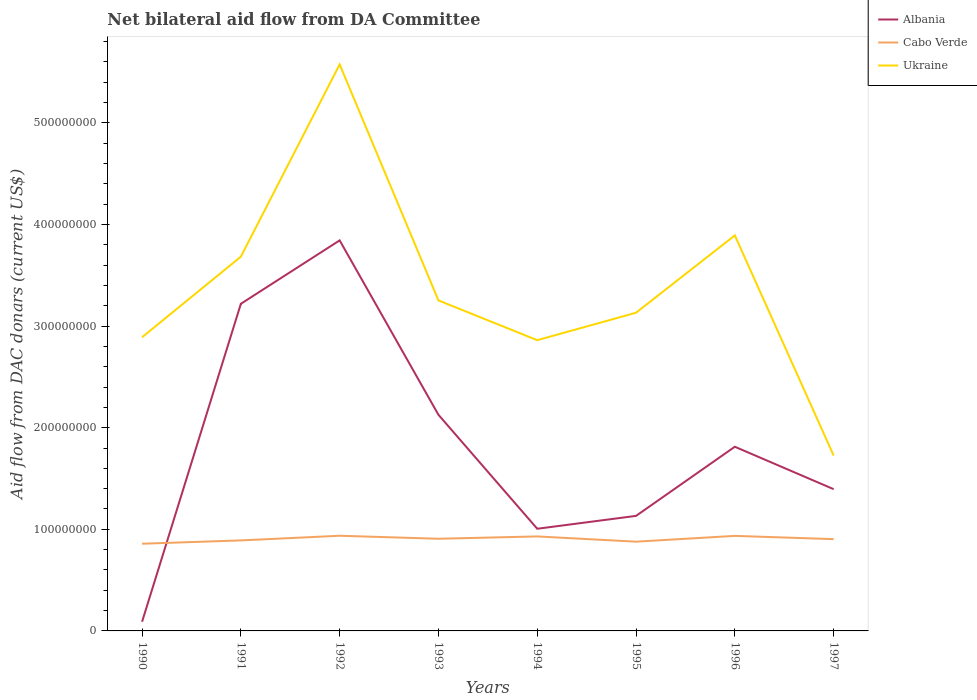How many different coloured lines are there?
Provide a succinct answer. 3. Across all years, what is the maximum aid flow in in Cabo Verde?
Keep it short and to the point. 8.58e+07. What is the total aid flow in in Cabo Verde in the graph?
Your answer should be compact. -4.59e+06. What is the difference between the highest and the second highest aid flow in in Cabo Verde?
Make the answer very short. 7.85e+06. Is the aid flow in in Albania strictly greater than the aid flow in in Cabo Verde over the years?
Ensure brevity in your answer.  No. How many years are there in the graph?
Your answer should be very brief. 8. What is the difference between two consecutive major ticks on the Y-axis?
Ensure brevity in your answer.  1.00e+08. Are the values on the major ticks of Y-axis written in scientific E-notation?
Your answer should be very brief. No. How are the legend labels stacked?
Offer a terse response. Vertical. What is the title of the graph?
Provide a short and direct response. Net bilateral aid flow from DA Committee. What is the label or title of the X-axis?
Offer a terse response. Years. What is the label or title of the Y-axis?
Provide a succinct answer. Aid flow from DAC donars (current US$). What is the Aid flow from DAC donars (current US$) in Albania in 1990?
Make the answer very short. 9.02e+06. What is the Aid flow from DAC donars (current US$) in Cabo Verde in 1990?
Ensure brevity in your answer.  8.58e+07. What is the Aid flow from DAC donars (current US$) in Ukraine in 1990?
Offer a terse response. 2.89e+08. What is the Aid flow from DAC donars (current US$) of Albania in 1991?
Give a very brief answer. 3.22e+08. What is the Aid flow from DAC donars (current US$) in Cabo Verde in 1991?
Keep it short and to the point. 8.91e+07. What is the Aid flow from DAC donars (current US$) of Ukraine in 1991?
Provide a succinct answer. 3.68e+08. What is the Aid flow from DAC donars (current US$) in Albania in 1992?
Give a very brief answer. 3.84e+08. What is the Aid flow from DAC donars (current US$) of Cabo Verde in 1992?
Give a very brief answer. 9.37e+07. What is the Aid flow from DAC donars (current US$) of Ukraine in 1992?
Keep it short and to the point. 5.57e+08. What is the Aid flow from DAC donars (current US$) in Albania in 1993?
Ensure brevity in your answer.  2.13e+08. What is the Aid flow from DAC donars (current US$) in Cabo Verde in 1993?
Keep it short and to the point. 9.07e+07. What is the Aid flow from DAC donars (current US$) in Ukraine in 1993?
Your answer should be very brief. 3.25e+08. What is the Aid flow from DAC donars (current US$) in Albania in 1994?
Make the answer very short. 1.01e+08. What is the Aid flow from DAC donars (current US$) in Cabo Verde in 1994?
Make the answer very short. 9.30e+07. What is the Aid flow from DAC donars (current US$) of Ukraine in 1994?
Your answer should be very brief. 2.86e+08. What is the Aid flow from DAC donars (current US$) in Albania in 1995?
Make the answer very short. 1.13e+08. What is the Aid flow from DAC donars (current US$) of Cabo Verde in 1995?
Ensure brevity in your answer.  8.78e+07. What is the Aid flow from DAC donars (current US$) of Ukraine in 1995?
Offer a terse response. 3.13e+08. What is the Aid flow from DAC donars (current US$) of Albania in 1996?
Offer a terse response. 1.81e+08. What is the Aid flow from DAC donars (current US$) of Cabo Verde in 1996?
Provide a short and direct response. 9.35e+07. What is the Aid flow from DAC donars (current US$) of Ukraine in 1996?
Your answer should be compact. 3.89e+08. What is the Aid flow from DAC donars (current US$) of Albania in 1997?
Provide a succinct answer. 1.40e+08. What is the Aid flow from DAC donars (current US$) of Cabo Verde in 1997?
Give a very brief answer. 9.03e+07. What is the Aid flow from DAC donars (current US$) of Ukraine in 1997?
Your answer should be very brief. 1.73e+08. Across all years, what is the maximum Aid flow from DAC donars (current US$) of Albania?
Make the answer very short. 3.84e+08. Across all years, what is the maximum Aid flow from DAC donars (current US$) in Cabo Verde?
Make the answer very short. 9.37e+07. Across all years, what is the maximum Aid flow from DAC donars (current US$) in Ukraine?
Make the answer very short. 5.57e+08. Across all years, what is the minimum Aid flow from DAC donars (current US$) of Albania?
Keep it short and to the point. 9.02e+06. Across all years, what is the minimum Aid flow from DAC donars (current US$) of Cabo Verde?
Your response must be concise. 8.58e+07. Across all years, what is the minimum Aid flow from DAC donars (current US$) in Ukraine?
Your answer should be very brief. 1.73e+08. What is the total Aid flow from DAC donars (current US$) in Albania in the graph?
Offer a terse response. 1.46e+09. What is the total Aid flow from DAC donars (current US$) in Cabo Verde in the graph?
Ensure brevity in your answer.  7.24e+08. What is the total Aid flow from DAC donars (current US$) in Ukraine in the graph?
Make the answer very short. 2.70e+09. What is the difference between the Aid flow from DAC donars (current US$) of Albania in 1990 and that in 1991?
Ensure brevity in your answer.  -3.13e+08. What is the difference between the Aid flow from DAC donars (current US$) of Cabo Verde in 1990 and that in 1991?
Offer a terse response. -3.26e+06. What is the difference between the Aid flow from DAC donars (current US$) of Ukraine in 1990 and that in 1991?
Ensure brevity in your answer.  -7.93e+07. What is the difference between the Aid flow from DAC donars (current US$) in Albania in 1990 and that in 1992?
Offer a very short reply. -3.75e+08. What is the difference between the Aid flow from DAC donars (current US$) in Cabo Verde in 1990 and that in 1992?
Your response must be concise. -7.85e+06. What is the difference between the Aid flow from DAC donars (current US$) in Ukraine in 1990 and that in 1992?
Your answer should be compact. -2.68e+08. What is the difference between the Aid flow from DAC donars (current US$) in Albania in 1990 and that in 1993?
Offer a very short reply. -2.04e+08. What is the difference between the Aid flow from DAC donars (current US$) in Cabo Verde in 1990 and that in 1993?
Your answer should be very brief. -4.90e+06. What is the difference between the Aid flow from DAC donars (current US$) in Ukraine in 1990 and that in 1993?
Make the answer very short. -3.62e+07. What is the difference between the Aid flow from DAC donars (current US$) in Albania in 1990 and that in 1994?
Offer a terse response. -9.15e+07. What is the difference between the Aid flow from DAC donars (current US$) in Cabo Verde in 1990 and that in 1994?
Ensure brevity in your answer.  -7.18e+06. What is the difference between the Aid flow from DAC donars (current US$) in Ukraine in 1990 and that in 1994?
Your answer should be very brief. 2.89e+06. What is the difference between the Aid flow from DAC donars (current US$) of Albania in 1990 and that in 1995?
Ensure brevity in your answer.  -1.04e+08. What is the difference between the Aid flow from DAC donars (current US$) of Cabo Verde in 1990 and that in 1995?
Offer a very short reply. -2.01e+06. What is the difference between the Aid flow from DAC donars (current US$) in Ukraine in 1990 and that in 1995?
Your answer should be compact. -2.41e+07. What is the difference between the Aid flow from DAC donars (current US$) of Albania in 1990 and that in 1996?
Provide a short and direct response. -1.72e+08. What is the difference between the Aid flow from DAC donars (current US$) of Cabo Verde in 1990 and that in 1996?
Provide a short and direct response. -7.72e+06. What is the difference between the Aid flow from DAC donars (current US$) of Ukraine in 1990 and that in 1996?
Your answer should be very brief. -1.00e+08. What is the difference between the Aid flow from DAC donars (current US$) of Albania in 1990 and that in 1997?
Your answer should be compact. -1.30e+08. What is the difference between the Aid flow from DAC donars (current US$) in Cabo Verde in 1990 and that in 1997?
Offer a terse response. -4.51e+06. What is the difference between the Aid flow from DAC donars (current US$) in Ukraine in 1990 and that in 1997?
Keep it short and to the point. 1.16e+08. What is the difference between the Aid flow from DAC donars (current US$) in Albania in 1991 and that in 1992?
Your response must be concise. -6.24e+07. What is the difference between the Aid flow from DAC donars (current US$) of Cabo Verde in 1991 and that in 1992?
Offer a very short reply. -4.59e+06. What is the difference between the Aid flow from DAC donars (current US$) of Ukraine in 1991 and that in 1992?
Offer a terse response. -1.89e+08. What is the difference between the Aid flow from DAC donars (current US$) of Albania in 1991 and that in 1993?
Ensure brevity in your answer.  1.09e+08. What is the difference between the Aid flow from DAC donars (current US$) of Cabo Verde in 1991 and that in 1993?
Ensure brevity in your answer.  -1.64e+06. What is the difference between the Aid flow from DAC donars (current US$) of Ukraine in 1991 and that in 1993?
Keep it short and to the point. 4.31e+07. What is the difference between the Aid flow from DAC donars (current US$) of Albania in 1991 and that in 1994?
Offer a very short reply. 2.21e+08. What is the difference between the Aid flow from DAC donars (current US$) of Cabo Verde in 1991 and that in 1994?
Your answer should be very brief. -3.92e+06. What is the difference between the Aid flow from DAC donars (current US$) in Ukraine in 1991 and that in 1994?
Provide a succinct answer. 8.22e+07. What is the difference between the Aid flow from DAC donars (current US$) in Albania in 1991 and that in 1995?
Offer a terse response. 2.09e+08. What is the difference between the Aid flow from DAC donars (current US$) of Cabo Verde in 1991 and that in 1995?
Make the answer very short. 1.25e+06. What is the difference between the Aid flow from DAC donars (current US$) of Ukraine in 1991 and that in 1995?
Provide a short and direct response. 5.52e+07. What is the difference between the Aid flow from DAC donars (current US$) in Albania in 1991 and that in 1996?
Offer a very short reply. 1.41e+08. What is the difference between the Aid flow from DAC donars (current US$) in Cabo Verde in 1991 and that in 1996?
Keep it short and to the point. -4.46e+06. What is the difference between the Aid flow from DAC donars (current US$) in Ukraine in 1991 and that in 1996?
Make the answer very short. -2.09e+07. What is the difference between the Aid flow from DAC donars (current US$) in Albania in 1991 and that in 1997?
Provide a short and direct response. 1.82e+08. What is the difference between the Aid flow from DAC donars (current US$) of Cabo Verde in 1991 and that in 1997?
Provide a short and direct response. -1.25e+06. What is the difference between the Aid flow from DAC donars (current US$) in Ukraine in 1991 and that in 1997?
Provide a short and direct response. 1.96e+08. What is the difference between the Aid flow from DAC donars (current US$) in Albania in 1992 and that in 1993?
Your answer should be compact. 1.72e+08. What is the difference between the Aid flow from DAC donars (current US$) in Cabo Verde in 1992 and that in 1993?
Provide a succinct answer. 2.95e+06. What is the difference between the Aid flow from DAC donars (current US$) of Ukraine in 1992 and that in 1993?
Make the answer very short. 2.32e+08. What is the difference between the Aid flow from DAC donars (current US$) of Albania in 1992 and that in 1994?
Keep it short and to the point. 2.84e+08. What is the difference between the Aid flow from DAC donars (current US$) of Cabo Verde in 1992 and that in 1994?
Your answer should be very brief. 6.70e+05. What is the difference between the Aid flow from DAC donars (current US$) in Ukraine in 1992 and that in 1994?
Provide a short and direct response. 2.71e+08. What is the difference between the Aid flow from DAC donars (current US$) of Albania in 1992 and that in 1995?
Provide a succinct answer. 2.71e+08. What is the difference between the Aid flow from DAC donars (current US$) in Cabo Verde in 1992 and that in 1995?
Your response must be concise. 5.84e+06. What is the difference between the Aid flow from DAC donars (current US$) in Ukraine in 1992 and that in 1995?
Provide a short and direct response. 2.44e+08. What is the difference between the Aid flow from DAC donars (current US$) of Albania in 1992 and that in 1996?
Your answer should be very brief. 2.03e+08. What is the difference between the Aid flow from DAC donars (current US$) of Cabo Verde in 1992 and that in 1996?
Offer a terse response. 1.30e+05. What is the difference between the Aid flow from DAC donars (current US$) in Ukraine in 1992 and that in 1996?
Your answer should be very brief. 1.68e+08. What is the difference between the Aid flow from DAC donars (current US$) of Albania in 1992 and that in 1997?
Provide a succinct answer. 2.45e+08. What is the difference between the Aid flow from DAC donars (current US$) in Cabo Verde in 1992 and that in 1997?
Offer a terse response. 3.34e+06. What is the difference between the Aid flow from DAC donars (current US$) of Ukraine in 1992 and that in 1997?
Provide a short and direct response. 3.85e+08. What is the difference between the Aid flow from DAC donars (current US$) in Albania in 1993 and that in 1994?
Provide a short and direct response. 1.12e+08. What is the difference between the Aid flow from DAC donars (current US$) in Cabo Verde in 1993 and that in 1994?
Your answer should be very brief. -2.28e+06. What is the difference between the Aid flow from DAC donars (current US$) of Ukraine in 1993 and that in 1994?
Offer a terse response. 3.91e+07. What is the difference between the Aid flow from DAC donars (current US$) of Albania in 1993 and that in 1995?
Provide a succinct answer. 9.95e+07. What is the difference between the Aid flow from DAC donars (current US$) of Cabo Verde in 1993 and that in 1995?
Give a very brief answer. 2.89e+06. What is the difference between the Aid flow from DAC donars (current US$) of Ukraine in 1993 and that in 1995?
Your response must be concise. 1.21e+07. What is the difference between the Aid flow from DAC donars (current US$) in Albania in 1993 and that in 1996?
Provide a short and direct response. 3.14e+07. What is the difference between the Aid flow from DAC donars (current US$) of Cabo Verde in 1993 and that in 1996?
Provide a short and direct response. -2.82e+06. What is the difference between the Aid flow from DAC donars (current US$) in Ukraine in 1993 and that in 1996?
Ensure brevity in your answer.  -6.40e+07. What is the difference between the Aid flow from DAC donars (current US$) of Albania in 1993 and that in 1997?
Your answer should be compact. 7.32e+07. What is the difference between the Aid flow from DAC donars (current US$) of Cabo Verde in 1993 and that in 1997?
Your answer should be compact. 3.90e+05. What is the difference between the Aid flow from DAC donars (current US$) in Ukraine in 1993 and that in 1997?
Ensure brevity in your answer.  1.53e+08. What is the difference between the Aid flow from DAC donars (current US$) in Albania in 1994 and that in 1995?
Offer a very short reply. -1.27e+07. What is the difference between the Aid flow from DAC donars (current US$) in Cabo Verde in 1994 and that in 1995?
Your answer should be very brief. 5.17e+06. What is the difference between the Aid flow from DAC donars (current US$) of Ukraine in 1994 and that in 1995?
Offer a terse response. -2.70e+07. What is the difference between the Aid flow from DAC donars (current US$) in Albania in 1994 and that in 1996?
Make the answer very short. -8.07e+07. What is the difference between the Aid flow from DAC donars (current US$) in Cabo Verde in 1994 and that in 1996?
Your response must be concise. -5.40e+05. What is the difference between the Aid flow from DAC donars (current US$) of Ukraine in 1994 and that in 1996?
Make the answer very short. -1.03e+08. What is the difference between the Aid flow from DAC donars (current US$) of Albania in 1994 and that in 1997?
Make the answer very short. -3.90e+07. What is the difference between the Aid flow from DAC donars (current US$) of Cabo Verde in 1994 and that in 1997?
Offer a terse response. 2.67e+06. What is the difference between the Aid flow from DAC donars (current US$) in Ukraine in 1994 and that in 1997?
Give a very brief answer. 1.14e+08. What is the difference between the Aid flow from DAC donars (current US$) of Albania in 1995 and that in 1996?
Make the answer very short. -6.80e+07. What is the difference between the Aid flow from DAC donars (current US$) of Cabo Verde in 1995 and that in 1996?
Give a very brief answer. -5.71e+06. What is the difference between the Aid flow from DAC donars (current US$) of Ukraine in 1995 and that in 1996?
Keep it short and to the point. -7.61e+07. What is the difference between the Aid flow from DAC donars (current US$) of Albania in 1995 and that in 1997?
Give a very brief answer. -2.63e+07. What is the difference between the Aid flow from DAC donars (current US$) of Cabo Verde in 1995 and that in 1997?
Your answer should be compact. -2.50e+06. What is the difference between the Aid flow from DAC donars (current US$) of Ukraine in 1995 and that in 1997?
Offer a terse response. 1.41e+08. What is the difference between the Aid flow from DAC donars (current US$) of Albania in 1996 and that in 1997?
Offer a very short reply. 4.17e+07. What is the difference between the Aid flow from DAC donars (current US$) in Cabo Verde in 1996 and that in 1997?
Offer a terse response. 3.21e+06. What is the difference between the Aid flow from DAC donars (current US$) in Ukraine in 1996 and that in 1997?
Offer a terse response. 2.17e+08. What is the difference between the Aid flow from DAC donars (current US$) of Albania in 1990 and the Aid flow from DAC donars (current US$) of Cabo Verde in 1991?
Make the answer very short. -8.00e+07. What is the difference between the Aid flow from DAC donars (current US$) of Albania in 1990 and the Aid flow from DAC donars (current US$) of Ukraine in 1991?
Provide a succinct answer. -3.59e+08. What is the difference between the Aid flow from DAC donars (current US$) of Cabo Verde in 1990 and the Aid flow from DAC donars (current US$) of Ukraine in 1991?
Offer a terse response. -2.82e+08. What is the difference between the Aid flow from DAC donars (current US$) in Albania in 1990 and the Aid flow from DAC donars (current US$) in Cabo Verde in 1992?
Offer a very short reply. -8.46e+07. What is the difference between the Aid flow from DAC donars (current US$) in Albania in 1990 and the Aid flow from DAC donars (current US$) in Ukraine in 1992?
Make the answer very short. -5.48e+08. What is the difference between the Aid flow from DAC donars (current US$) in Cabo Verde in 1990 and the Aid flow from DAC donars (current US$) in Ukraine in 1992?
Provide a short and direct response. -4.72e+08. What is the difference between the Aid flow from DAC donars (current US$) of Albania in 1990 and the Aid flow from DAC donars (current US$) of Cabo Verde in 1993?
Provide a short and direct response. -8.17e+07. What is the difference between the Aid flow from DAC donars (current US$) of Albania in 1990 and the Aid flow from DAC donars (current US$) of Ukraine in 1993?
Your response must be concise. -3.16e+08. What is the difference between the Aid flow from DAC donars (current US$) in Cabo Verde in 1990 and the Aid flow from DAC donars (current US$) in Ukraine in 1993?
Give a very brief answer. -2.39e+08. What is the difference between the Aid flow from DAC donars (current US$) in Albania in 1990 and the Aid flow from DAC donars (current US$) in Cabo Verde in 1994?
Your response must be concise. -8.40e+07. What is the difference between the Aid flow from DAC donars (current US$) in Albania in 1990 and the Aid flow from DAC donars (current US$) in Ukraine in 1994?
Ensure brevity in your answer.  -2.77e+08. What is the difference between the Aid flow from DAC donars (current US$) of Cabo Verde in 1990 and the Aid flow from DAC donars (current US$) of Ukraine in 1994?
Make the answer very short. -2.00e+08. What is the difference between the Aid flow from DAC donars (current US$) of Albania in 1990 and the Aid flow from DAC donars (current US$) of Cabo Verde in 1995?
Keep it short and to the point. -7.88e+07. What is the difference between the Aid flow from DAC donars (current US$) in Albania in 1990 and the Aid flow from DAC donars (current US$) in Ukraine in 1995?
Your answer should be very brief. -3.04e+08. What is the difference between the Aid flow from DAC donars (current US$) in Cabo Verde in 1990 and the Aid flow from DAC donars (current US$) in Ukraine in 1995?
Make the answer very short. -2.27e+08. What is the difference between the Aid flow from DAC donars (current US$) of Albania in 1990 and the Aid flow from DAC donars (current US$) of Cabo Verde in 1996?
Your answer should be compact. -8.45e+07. What is the difference between the Aid flow from DAC donars (current US$) of Albania in 1990 and the Aid flow from DAC donars (current US$) of Ukraine in 1996?
Provide a succinct answer. -3.80e+08. What is the difference between the Aid flow from DAC donars (current US$) in Cabo Verde in 1990 and the Aid flow from DAC donars (current US$) in Ukraine in 1996?
Give a very brief answer. -3.03e+08. What is the difference between the Aid flow from DAC donars (current US$) in Albania in 1990 and the Aid flow from DAC donars (current US$) in Cabo Verde in 1997?
Give a very brief answer. -8.13e+07. What is the difference between the Aid flow from DAC donars (current US$) in Albania in 1990 and the Aid flow from DAC donars (current US$) in Ukraine in 1997?
Your response must be concise. -1.64e+08. What is the difference between the Aid flow from DAC donars (current US$) of Cabo Verde in 1990 and the Aid flow from DAC donars (current US$) of Ukraine in 1997?
Provide a succinct answer. -8.68e+07. What is the difference between the Aid flow from DAC donars (current US$) in Albania in 1991 and the Aid flow from DAC donars (current US$) in Cabo Verde in 1992?
Your answer should be compact. 2.28e+08. What is the difference between the Aid flow from DAC donars (current US$) in Albania in 1991 and the Aid flow from DAC donars (current US$) in Ukraine in 1992?
Provide a short and direct response. -2.36e+08. What is the difference between the Aid flow from DAC donars (current US$) of Cabo Verde in 1991 and the Aid flow from DAC donars (current US$) of Ukraine in 1992?
Provide a short and direct response. -4.68e+08. What is the difference between the Aid flow from DAC donars (current US$) in Albania in 1991 and the Aid flow from DAC donars (current US$) in Cabo Verde in 1993?
Your answer should be compact. 2.31e+08. What is the difference between the Aid flow from DAC donars (current US$) of Albania in 1991 and the Aid flow from DAC donars (current US$) of Ukraine in 1993?
Ensure brevity in your answer.  -3.31e+06. What is the difference between the Aid flow from DAC donars (current US$) of Cabo Verde in 1991 and the Aid flow from DAC donars (current US$) of Ukraine in 1993?
Give a very brief answer. -2.36e+08. What is the difference between the Aid flow from DAC donars (current US$) of Albania in 1991 and the Aid flow from DAC donars (current US$) of Cabo Verde in 1994?
Ensure brevity in your answer.  2.29e+08. What is the difference between the Aid flow from DAC donars (current US$) of Albania in 1991 and the Aid flow from DAC donars (current US$) of Ukraine in 1994?
Give a very brief answer. 3.58e+07. What is the difference between the Aid flow from DAC donars (current US$) in Cabo Verde in 1991 and the Aid flow from DAC donars (current US$) in Ukraine in 1994?
Provide a short and direct response. -1.97e+08. What is the difference between the Aid flow from DAC donars (current US$) in Albania in 1991 and the Aid flow from DAC donars (current US$) in Cabo Verde in 1995?
Make the answer very short. 2.34e+08. What is the difference between the Aid flow from DAC donars (current US$) in Albania in 1991 and the Aid flow from DAC donars (current US$) in Ukraine in 1995?
Provide a short and direct response. 8.79e+06. What is the difference between the Aid flow from DAC donars (current US$) in Cabo Verde in 1991 and the Aid flow from DAC donars (current US$) in Ukraine in 1995?
Give a very brief answer. -2.24e+08. What is the difference between the Aid flow from DAC donars (current US$) in Albania in 1991 and the Aid flow from DAC donars (current US$) in Cabo Verde in 1996?
Provide a short and direct response. 2.28e+08. What is the difference between the Aid flow from DAC donars (current US$) in Albania in 1991 and the Aid flow from DAC donars (current US$) in Ukraine in 1996?
Your answer should be very brief. -6.73e+07. What is the difference between the Aid flow from DAC donars (current US$) in Cabo Verde in 1991 and the Aid flow from DAC donars (current US$) in Ukraine in 1996?
Give a very brief answer. -3.00e+08. What is the difference between the Aid flow from DAC donars (current US$) in Albania in 1991 and the Aid flow from DAC donars (current US$) in Cabo Verde in 1997?
Your answer should be compact. 2.32e+08. What is the difference between the Aid flow from DAC donars (current US$) of Albania in 1991 and the Aid flow from DAC donars (current US$) of Ukraine in 1997?
Your answer should be compact. 1.49e+08. What is the difference between the Aid flow from DAC donars (current US$) of Cabo Verde in 1991 and the Aid flow from DAC donars (current US$) of Ukraine in 1997?
Your answer should be compact. -8.35e+07. What is the difference between the Aid flow from DAC donars (current US$) in Albania in 1992 and the Aid flow from DAC donars (current US$) in Cabo Verde in 1993?
Provide a short and direct response. 2.94e+08. What is the difference between the Aid flow from DAC donars (current US$) of Albania in 1992 and the Aid flow from DAC donars (current US$) of Ukraine in 1993?
Give a very brief answer. 5.91e+07. What is the difference between the Aid flow from DAC donars (current US$) in Cabo Verde in 1992 and the Aid flow from DAC donars (current US$) in Ukraine in 1993?
Offer a terse response. -2.32e+08. What is the difference between the Aid flow from DAC donars (current US$) in Albania in 1992 and the Aid flow from DAC donars (current US$) in Cabo Verde in 1994?
Keep it short and to the point. 2.91e+08. What is the difference between the Aid flow from DAC donars (current US$) of Albania in 1992 and the Aid flow from DAC donars (current US$) of Ukraine in 1994?
Your response must be concise. 9.82e+07. What is the difference between the Aid flow from DAC donars (current US$) of Cabo Verde in 1992 and the Aid flow from DAC donars (current US$) of Ukraine in 1994?
Make the answer very short. -1.92e+08. What is the difference between the Aid flow from DAC donars (current US$) in Albania in 1992 and the Aid flow from DAC donars (current US$) in Cabo Verde in 1995?
Your answer should be very brief. 2.96e+08. What is the difference between the Aid flow from DAC donars (current US$) in Albania in 1992 and the Aid flow from DAC donars (current US$) in Ukraine in 1995?
Make the answer very short. 7.12e+07. What is the difference between the Aid flow from DAC donars (current US$) in Cabo Verde in 1992 and the Aid flow from DAC donars (current US$) in Ukraine in 1995?
Your answer should be compact. -2.19e+08. What is the difference between the Aid flow from DAC donars (current US$) in Albania in 1992 and the Aid flow from DAC donars (current US$) in Cabo Verde in 1996?
Give a very brief answer. 2.91e+08. What is the difference between the Aid flow from DAC donars (current US$) of Albania in 1992 and the Aid flow from DAC donars (current US$) of Ukraine in 1996?
Offer a very short reply. -4.90e+06. What is the difference between the Aid flow from DAC donars (current US$) in Cabo Verde in 1992 and the Aid flow from DAC donars (current US$) in Ukraine in 1996?
Give a very brief answer. -2.96e+08. What is the difference between the Aid flow from DAC donars (current US$) of Albania in 1992 and the Aid flow from DAC donars (current US$) of Cabo Verde in 1997?
Provide a short and direct response. 2.94e+08. What is the difference between the Aid flow from DAC donars (current US$) in Albania in 1992 and the Aid flow from DAC donars (current US$) in Ukraine in 1997?
Give a very brief answer. 2.12e+08. What is the difference between the Aid flow from DAC donars (current US$) of Cabo Verde in 1992 and the Aid flow from DAC donars (current US$) of Ukraine in 1997?
Make the answer very short. -7.89e+07. What is the difference between the Aid flow from DAC donars (current US$) in Albania in 1993 and the Aid flow from DAC donars (current US$) in Cabo Verde in 1994?
Your answer should be very brief. 1.20e+08. What is the difference between the Aid flow from DAC donars (current US$) in Albania in 1993 and the Aid flow from DAC donars (current US$) in Ukraine in 1994?
Your answer should be very brief. -7.34e+07. What is the difference between the Aid flow from DAC donars (current US$) of Cabo Verde in 1993 and the Aid flow from DAC donars (current US$) of Ukraine in 1994?
Provide a succinct answer. -1.95e+08. What is the difference between the Aid flow from DAC donars (current US$) in Albania in 1993 and the Aid flow from DAC donars (current US$) in Cabo Verde in 1995?
Your answer should be very brief. 1.25e+08. What is the difference between the Aid flow from DAC donars (current US$) in Albania in 1993 and the Aid flow from DAC donars (current US$) in Ukraine in 1995?
Provide a succinct answer. -1.00e+08. What is the difference between the Aid flow from DAC donars (current US$) in Cabo Verde in 1993 and the Aid flow from DAC donars (current US$) in Ukraine in 1995?
Ensure brevity in your answer.  -2.22e+08. What is the difference between the Aid flow from DAC donars (current US$) in Albania in 1993 and the Aid flow from DAC donars (current US$) in Cabo Verde in 1996?
Keep it short and to the point. 1.19e+08. What is the difference between the Aid flow from DAC donars (current US$) in Albania in 1993 and the Aid flow from DAC donars (current US$) in Ukraine in 1996?
Make the answer very short. -1.77e+08. What is the difference between the Aid flow from DAC donars (current US$) in Cabo Verde in 1993 and the Aid flow from DAC donars (current US$) in Ukraine in 1996?
Provide a succinct answer. -2.99e+08. What is the difference between the Aid flow from DAC donars (current US$) of Albania in 1993 and the Aid flow from DAC donars (current US$) of Cabo Verde in 1997?
Give a very brief answer. 1.22e+08. What is the difference between the Aid flow from DAC donars (current US$) in Albania in 1993 and the Aid flow from DAC donars (current US$) in Ukraine in 1997?
Your answer should be compact. 4.01e+07. What is the difference between the Aid flow from DAC donars (current US$) of Cabo Verde in 1993 and the Aid flow from DAC donars (current US$) of Ukraine in 1997?
Give a very brief answer. -8.19e+07. What is the difference between the Aid flow from DAC donars (current US$) in Albania in 1994 and the Aid flow from DAC donars (current US$) in Cabo Verde in 1995?
Your response must be concise. 1.27e+07. What is the difference between the Aid flow from DAC donars (current US$) in Albania in 1994 and the Aid flow from DAC donars (current US$) in Ukraine in 1995?
Make the answer very short. -2.13e+08. What is the difference between the Aid flow from DAC donars (current US$) in Cabo Verde in 1994 and the Aid flow from DAC donars (current US$) in Ukraine in 1995?
Offer a terse response. -2.20e+08. What is the difference between the Aid flow from DAC donars (current US$) in Albania in 1994 and the Aid flow from DAC donars (current US$) in Cabo Verde in 1996?
Offer a terse response. 7.01e+06. What is the difference between the Aid flow from DAC donars (current US$) of Albania in 1994 and the Aid flow from DAC donars (current US$) of Ukraine in 1996?
Provide a short and direct response. -2.89e+08. What is the difference between the Aid flow from DAC donars (current US$) of Cabo Verde in 1994 and the Aid flow from DAC donars (current US$) of Ukraine in 1996?
Give a very brief answer. -2.96e+08. What is the difference between the Aid flow from DAC donars (current US$) of Albania in 1994 and the Aid flow from DAC donars (current US$) of Cabo Verde in 1997?
Ensure brevity in your answer.  1.02e+07. What is the difference between the Aid flow from DAC donars (current US$) of Albania in 1994 and the Aid flow from DAC donars (current US$) of Ukraine in 1997?
Offer a terse response. -7.21e+07. What is the difference between the Aid flow from DAC donars (current US$) of Cabo Verde in 1994 and the Aid flow from DAC donars (current US$) of Ukraine in 1997?
Offer a terse response. -7.96e+07. What is the difference between the Aid flow from DAC donars (current US$) of Albania in 1995 and the Aid flow from DAC donars (current US$) of Cabo Verde in 1996?
Provide a short and direct response. 1.97e+07. What is the difference between the Aid flow from DAC donars (current US$) in Albania in 1995 and the Aid flow from DAC donars (current US$) in Ukraine in 1996?
Make the answer very short. -2.76e+08. What is the difference between the Aid flow from DAC donars (current US$) of Cabo Verde in 1995 and the Aid flow from DAC donars (current US$) of Ukraine in 1996?
Give a very brief answer. -3.01e+08. What is the difference between the Aid flow from DAC donars (current US$) in Albania in 1995 and the Aid flow from DAC donars (current US$) in Cabo Verde in 1997?
Provide a succinct answer. 2.29e+07. What is the difference between the Aid flow from DAC donars (current US$) of Albania in 1995 and the Aid flow from DAC donars (current US$) of Ukraine in 1997?
Give a very brief answer. -5.94e+07. What is the difference between the Aid flow from DAC donars (current US$) of Cabo Verde in 1995 and the Aid flow from DAC donars (current US$) of Ukraine in 1997?
Provide a short and direct response. -8.48e+07. What is the difference between the Aid flow from DAC donars (current US$) in Albania in 1996 and the Aid flow from DAC donars (current US$) in Cabo Verde in 1997?
Give a very brief answer. 9.09e+07. What is the difference between the Aid flow from DAC donars (current US$) of Albania in 1996 and the Aid flow from DAC donars (current US$) of Ukraine in 1997?
Your answer should be compact. 8.64e+06. What is the difference between the Aid flow from DAC donars (current US$) of Cabo Verde in 1996 and the Aid flow from DAC donars (current US$) of Ukraine in 1997?
Offer a very short reply. -7.91e+07. What is the average Aid flow from DAC donars (current US$) in Albania per year?
Your answer should be compact. 1.83e+08. What is the average Aid flow from DAC donars (current US$) in Cabo Verde per year?
Ensure brevity in your answer.  9.05e+07. What is the average Aid flow from DAC donars (current US$) in Ukraine per year?
Your response must be concise. 3.38e+08. In the year 1990, what is the difference between the Aid flow from DAC donars (current US$) in Albania and Aid flow from DAC donars (current US$) in Cabo Verde?
Ensure brevity in your answer.  -7.68e+07. In the year 1990, what is the difference between the Aid flow from DAC donars (current US$) of Albania and Aid flow from DAC donars (current US$) of Ukraine?
Ensure brevity in your answer.  -2.80e+08. In the year 1990, what is the difference between the Aid flow from DAC donars (current US$) of Cabo Verde and Aid flow from DAC donars (current US$) of Ukraine?
Your answer should be very brief. -2.03e+08. In the year 1991, what is the difference between the Aid flow from DAC donars (current US$) in Albania and Aid flow from DAC donars (current US$) in Cabo Verde?
Give a very brief answer. 2.33e+08. In the year 1991, what is the difference between the Aid flow from DAC donars (current US$) in Albania and Aid flow from DAC donars (current US$) in Ukraine?
Offer a very short reply. -4.64e+07. In the year 1991, what is the difference between the Aid flow from DAC donars (current US$) of Cabo Verde and Aid flow from DAC donars (current US$) of Ukraine?
Provide a short and direct response. -2.79e+08. In the year 1992, what is the difference between the Aid flow from DAC donars (current US$) in Albania and Aid flow from DAC donars (current US$) in Cabo Verde?
Keep it short and to the point. 2.91e+08. In the year 1992, what is the difference between the Aid flow from DAC donars (current US$) in Albania and Aid flow from DAC donars (current US$) in Ukraine?
Offer a very short reply. -1.73e+08. In the year 1992, what is the difference between the Aid flow from DAC donars (current US$) of Cabo Verde and Aid flow from DAC donars (current US$) of Ukraine?
Your answer should be very brief. -4.64e+08. In the year 1993, what is the difference between the Aid flow from DAC donars (current US$) of Albania and Aid flow from DAC donars (current US$) of Cabo Verde?
Provide a succinct answer. 1.22e+08. In the year 1993, what is the difference between the Aid flow from DAC donars (current US$) in Albania and Aid flow from DAC donars (current US$) in Ukraine?
Keep it short and to the point. -1.13e+08. In the year 1993, what is the difference between the Aid flow from DAC donars (current US$) in Cabo Verde and Aid flow from DAC donars (current US$) in Ukraine?
Offer a very short reply. -2.35e+08. In the year 1994, what is the difference between the Aid flow from DAC donars (current US$) of Albania and Aid flow from DAC donars (current US$) of Cabo Verde?
Keep it short and to the point. 7.55e+06. In the year 1994, what is the difference between the Aid flow from DAC donars (current US$) in Albania and Aid flow from DAC donars (current US$) in Ukraine?
Offer a terse response. -1.86e+08. In the year 1994, what is the difference between the Aid flow from DAC donars (current US$) in Cabo Verde and Aid flow from DAC donars (current US$) in Ukraine?
Ensure brevity in your answer.  -1.93e+08. In the year 1995, what is the difference between the Aid flow from DAC donars (current US$) in Albania and Aid flow from DAC donars (current US$) in Cabo Verde?
Make the answer very short. 2.54e+07. In the year 1995, what is the difference between the Aid flow from DAC donars (current US$) in Albania and Aid flow from DAC donars (current US$) in Ukraine?
Give a very brief answer. -2.00e+08. In the year 1995, what is the difference between the Aid flow from DAC donars (current US$) in Cabo Verde and Aid flow from DAC donars (current US$) in Ukraine?
Your answer should be compact. -2.25e+08. In the year 1996, what is the difference between the Aid flow from DAC donars (current US$) in Albania and Aid flow from DAC donars (current US$) in Cabo Verde?
Offer a very short reply. 8.77e+07. In the year 1996, what is the difference between the Aid flow from DAC donars (current US$) in Albania and Aid flow from DAC donars (current US$) in Ukraine?
Offer a very short reply. -2.08e+08. In the year 1996, what is the difference between the Aid flow from DAC donars (current US$) of Cabo Verde and Aid flow from DAC donars (current US$) of Ukraine?
Provide a succinct answer. -2.96e+08. In the year 1997, what is the difference between the Aid flow from DAC donars (current US$) in Albania and Aid flow from DAC donars (current US$) in Cabo Verde?
Ensure brevity in your answer.  4.92e+07. In the year 1997, what is the difference between the Aid flow from DAC donars (current US$) in Albania and Aid flow from DAC donars (current US$) in Ukraine?
Provide a succinct answer. -3.31e+07. In the year 1997, what is the difference between the Aid flow from DAC donars (current US$) of Cabo Verde and Aid flow from DAC donars (current US$) of Ukraine?
Offer a very short reply. -8.23e+07. What is the ratio of the Aid flow from DAC donars (current US$) of Albania in 1990 to that in 1991?
Ensure brevity in your answer.  0.03. What is the ratio of the Aid flow from DAC donars (current US$) of Cabo Verde in 1990 to that in 1991?
Your answer should be compact. 0.96. What is the ratio of the Aid flow from DAC donars (current US$) in Ukraine in 1990 to that in 1991?
Ensure brevity in your answer.  0.78. What is the ratio of the Aid flow from DAC donars (current US$) of Albania in 1990 to that in 1992?
Keep it short and to the point. 0.02. What is the ratio of the Aid flow from DAC donars (current US$) of Cabo Verde in 1990 to that in 1992?
Your answer should be very brief. 0.92. What is the ratio of the Aid flow from DAC donars (current US$) in Ukraine in 1990 to that in 1992?
Your answer should be compact. 0.52. What is the ratio of the Aid flow from DAC donars (current US$) in Albania in 1990 to that in 1993?
Ensure brevity in your answer.  0.04. What is the ratio of the Aid flow from DAC donars (current US$) in Cabo Verde in 1990 to that in 1993?
Ensure brevity in your answer.  0.95. What is the ratio of the Aid flow from DAC donars (current US$) of Ukraine in 1990 to that in 1993?
Make the answer very short. 0.89. What is the ratio of the Aid flow from DAC donars (current US$) in Albania in 1990 to that in 1994?
Your response must be concise. 0.09. What is the ratio of the Aid flow from DAC donars (current US$) of Cabo Verde in 1990 to that in 1994?
Provide a succinct answer. 0.92. What is the ratio of the Aid flow from DAC donars (current US$) in Ukraine in 1990 to that in 1994?
Provide a succinct answer. 1.01. What is the ratio of the Aid flow from DAC donars (current US$) of Albania in 1990 to that in 1995?
Give a very brief answer. 0.08. What is the ratio of the Aid flow from DAC donars (current US$) of Cabo Verde in 1990 to that in 1995?
Keep it short and to the point. 0.98. What is the ratio of the Aid flow from DAC donars (current US$) in Ukraine in 1990 to that in 1995?
Ensure brevity in your answer.  0.92. What is the ratio of the Aid flow from DAC donars (current US$) of Albania in 1990 to that in 1996?
Your answer should be very brief. 0.05. What is the ratio of the Aid flow from DAC donars (current US$) of Cabo Verde in 1990 to that in 1996?
Your response must be concise. 0.92. What is the ratio of the Aid flow from DAC donars (current US$) in Ukraine in 1990 to that in 1996?
Your answer should be compact. 0.74. What is the ratio of the Aid flow from DAC donars (current US$) in Albania in 1990 to that in 1997?
Offer a terse response. 0.06. What is the ratio of the Aid flow from DAC donars (current US$) in Cabo Verde in 1990 to that in 1997?
Offer a very short reply. 0.95. What is the ratio of the Aid flow from DAC donars (current US$) in Ukraine in 1990 to that in 1997?
Ensure brevity in your answer.  1.67. What is the ratio of the Aid flow from DAC donars (current US$) in Albania in 1991 to that in 1992?
Make the answer very short. 0.84. What is the ratio of the Aid flow from DAC donars (current US$) in Cabo Verde in 1991 to that in 1992?
Provide a short and direct response. 0.95. What is the ratio of the Aid flow from DAC donars (current US$) of Ukraine in 1991 to that in 1992?
Provide a succinct answer. 0.66. What is the ratio of the Aid flow from DAC donars (current US$) of Albania in 1991 to that in 1993?
Give a very brief answer. 1.51. What is the ratio of the Aid flow from DAC donars (current US$) in Cabo Verde in 1991 to that in 1993?
Your response must be concise. 0.98. What is the ratio of the Aid flow from DAC donars (current US$) in Ukraine in 1991 to that in 1993?
Provide a short and direct response. 1.13. What is the ratio of the Aid flow from DAC donars (current US$) in Albania in 1991 to that in 1994?
Your response must be concise. 3.2. What is the ratio of the Aid flow from DAC donars (current US$) of Cabo Verde in 1991 to that in 1994?
Make the answer very short. 0.96. What is the ratio of the Aid flow from DAC donars (current US$) in Ukraine in 1991 to that in 1994?
Ensure brevity in your answer.  1.29. What is the ratio of the Aid flow from DAC donars (current US$) in Albania in 1991 to that in 1995?
Offer a very short reply. 2.84. What is the ratio of the Aid flow from DAC donars (current US$) in Cabo Verde in 1991 to that in 1995?
Keep it short and to the point. 1.01. What is the ratio of the Aid flow from DAC donars (current US$) of Ukraine in 1991 to that in 1995?
Offer a very short reply. 1.18. What is the ratio of the Aid flow from DAC donars (current US$) of Albania in 1991 to that in 1996?
Your answer should be compact. 1.78. What is the ratio of the Aid flow from DAC donars (current US$) of Cabo Verde in 1991 to that in 1996?
Provide a succinct answer. 0.95. What is the ratio of the Aid flow from DAC donars (current US$) in Ukraine in 1991 to that in 1996?
Provide a short and direct response. 0.95. What is the ratio of the Aid flow from DAC donars (current US$) in Albania in 1991 to that in 1997?
Offer a very short reply. 2.31. What is the ratio of the Aid flow from DAC donars (current US$) in Cabo Verde in 1991 to that in 1997?
Provide a short and direct response. 0.99. What is the ratio of the Aid flow from DAC donars (current US$) in Ukraine in 1991 to that in 1997?
Give a very brief answer. 2.13. What is the ratio of the Aid flow from DAC donars (current US$) in Albania in 1992 to that in 1993?
Your answer should be very brief. 1.81. What is the ratio of the Aid flow from DAC donars (current US$) of Cabo Verde in 1992 to that in 1993?
Your response must be concise. 1.03. What is the ratio of the Aid flow from DAC donars (current US$) in Ukraine in 1992 to that in 1993?
Provide a succinct answer. 1.71. What is the ratio of the Aid flow from DAC donars (current US$) in Albania in 1992 to that in 1994?
Make the answer very short. 3.82. What is the ratio of the Aid flow from DAC donars (current US$) in Cabo Verde in 1992 to that in 1994?
Offer a very short reply. 1.01. What is the ratio of the Aid flow from DAC donars (current US$) in Ukraine in 1992 to that in 1994?
Provide a succinct answer. 1.95. What is the ratio of the Aid flow from DAC donars (current US$) in Albania in 1992 to that in 1995?
Offer a terse response. 3.4. What is the ratio of the Aid flow from DAC donars (current US$) of Cabo Verde in 1992 to that in 1995?
Offer a very short reply. 1.07. What is the ratio of the Aid flow from DAC donars (current US$) of Ukraine in 1992 to that in 1995?
Make the answer very short. 1.78. What is the ratio of the Aid flow from DAC donars (current US$) in Albania in 1992 to that in 1996?
Your answer should be very brief. 2.12. What is the ratio of the Aid flow from DAC donars (current US$) in Ukraine in 1992 to that in 1996?
Provide a short and direct response. 1.43. What is the ratio of the Aid flow from DAC donars (current US$) of Albania in 1992 to that in 1997?
Make the answer very short. 2.75. What is the ratio of the Aid flow from DAC donars (current US$) of Ukraine in 1992 to that in 1997?
Your answer should be compact. 3.23. What is the ratio of the Aid flow from DAC donars (current US$) of Albania in 1993 to that in 1994?
Ensure brevity in your answer.  2.12. What is the ratio of the Aid flow from DAC donars (current US$) of Cabo Verde in 1993 to that in 1994?
Keep it short and to the point. 0.98. What is the ratio of the Aid flow from DAC donars (current US$) in Ukraine in 1993 to that in 1994?
Offer a terse response. 1.14. What is the ratio of the Aid flow from DAC donars (current US$) in Albania in 1993 to that in 1995?
Offer a terse response. 1.88. What is the ratio of the Aid flow from DAC donars (current US$) in Cabo Verde in 1993 to that in 1995?
Make the answer very short. 1.03. What is the ratio of the Aid flow from DAC donars (current US$) of Ukraine in 1993 to that in 1995?
Make the answer very short. 1.04. What is the ratio of the Aid flow from DAC donars (current US$) of Albania in 1993 to that in 1996?
Give a very brief answer. 1.17. What is the ratio of the Aid flow from DAC donars (current US$) of Cabo Verde in 1993 to that in 1996?
Make the answer very short. 0.97. What is the ratio of the Aid flow from DAC donars (current US$) of Ukraine in 1993 to that in 1996?
Give a very brief answer. 0.84. What is the ratio of the Aid flow from DAC donars (current US$) in Albania in 1993 to that in 1997?
Your response must be concise. 1.52. What is the ratio of the Aid flow from DAC donars (current US$) of Ukraine in 1993 to that in 1997?
Offer a very short reply. 1.88. What is the ratio of the Aid flow from DAC donars (current US$) of Albania in 1994 to that in 1995?
Your answer should be very brief. 0.89. What is the ratio of the Aid flow from DAC donars (current US$) in Cabo Verde in 1994 to that in 1995?
Offer a very short reply. 1.06. What is the ratio of the Aid flow from DAC donars (current US$) in Ukraine in 1994 to that in 1995?
Provide a short and direct response. 0.91. What is the ratio of the Aid flow from DAC donars (current US$) of Albania in 1994 to that in 1996?
Give a very brief answer. 0.55. What is the ratio of the Aid flow from DAC donars (current US$) of Cabo Verde in 1994 to that in 1996?
Provide a short and direct response. 0.99. What is the ratio of the Aid flow from DAC donars (current US$) of Ukraine in 1994 to that in 1996?
Provide a succinct answer. 0.74. What is the ratio of the Aid flow from DAC donars (current US$) of Albania in 1994 to that in 1997?
Your response must be concise. 0.72. What is the ratio of the Aid flow from DAC donars (current US$) of Cabo Verde in 1994 to that in 1997?
Offer a terse response. 1.03. What is the ratio of the Aid flow from DAC donars (current US$) of Ukraine in 1994 to that in 1997?
Ensure brevity in your answer.  1.66. What is the ratio of the Aid flow from DAC donars (current US$) in Albania in 1995 to that in 1996?
Provide a short and direct response. 0.62. What is the ratio of the Aid flow from DAC donars (current US$) in Cabo Verde in 1995 to that in 1996?
Ensure brevity in your answer.  0.94. What is the ratio of the Aid flow from DAC donars (current US$) of Ukraine in 1995 to that in 1996?
Give a very brief answer. 0.8. What is the ratio of the Aid flow from DAC donars (current US$) in Albania in 1995 to that in 1997?
Offer a terse response. 0.81. What is the ratio of the Aid flow from DAC donars (current US$) in Cabo Verde in 1995 to that in 1997?
Offer a very short reply. 0.97. What is the ratio of the Aid flow from DAC donars (current US$) of Ukraine in 1995 to that in 1997?
Give a very brief answer. 1.81. What is the ratio of the Aid flow from DAC donars (current US$) in Albania in 1996 to that in 1997?
Offer a terse response. 1.3. What is the ratio of the Aid flow from DAC donars (current US$) of Cabo Verde in 1996 to that in 1997?
Offer a terse response. 1.04. What is the ratio of the Aid flow from DAC donars (current US$) in Ukraine in 1996 to that in 1997?
Your response must be concise. 2.25. What is the difference between the highest and the second highest Aid flow from DAC donars (current US$) in Albania?
Provide a short and direct response. 6.24e+07. What is the difference between the highest and the second highest Aid flow from DAC donars (current US$) of Ukraine?
Offer a terse response. 1.68e+08. What is the difference between the highest and the lowest Aid flow from DAC donars (current US$) of Albania?
Provide a succinct answer. 3.75e+08. What is the difference between the highest and the lowest Aid flow from DAC donars (current US$) of Cabo Verde?
Offer a very short reply. 7.85e+06. What is the difference between the highest and the lowest Aid flow from DAC donars (current US$) of Ukraine?
Ensure brevity in your answer.  3.85e+08. 